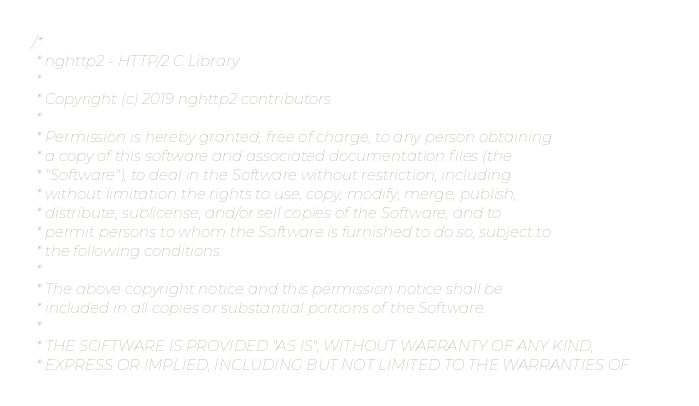<code> <loc_0><loc_0><loc_500><loc_500><_C++_>/*
 * nghttp2 - HTTP/2 C Library
 *
 * Copyright (c) 2019 nghttp2 contributors
 *
 * Permission is hereby granted, free of charge, to any person obtaining
 * a copy of this software and associated documentation files (the
 * "Software"), to deal in the Software without restriction, including
 * without limitation the rights to use, copy, modify, merge, publish,
 * distribute, sublicense, and/or sell copies of the Software, and to
 * permit persons to whom the Software is furnished to do so, subject to
 * the following conditions:
 *
 * The above copyright notice and this permission notice shall be
 * included in all copies or substantial portions of the Software.
 *
 * THE SOFTWARE IS PROVIDED "AS IS", WITHOUT WARRANTY OF ANY KIND,
 * EXPRESS OR IMPLIED, INCLUDING BUT NOT LIMITED TO THE WARRANTIES OF</code> 